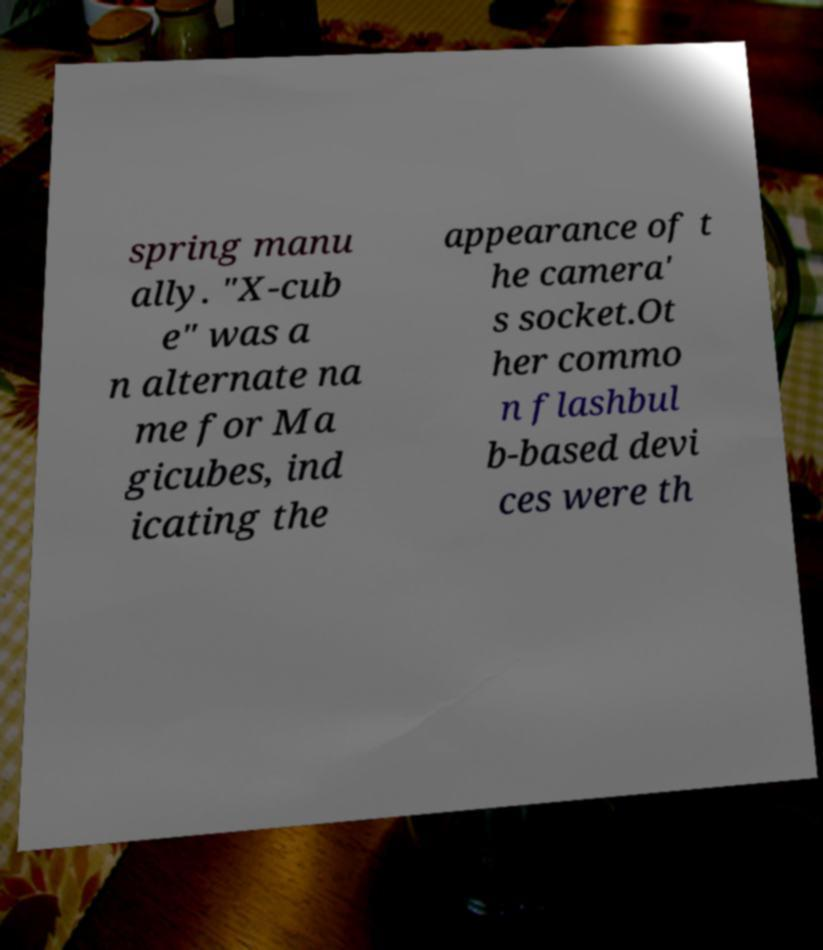Can you accurately transcribe the text from the provided image for me? spring manu ally. "X-cub e" was a n alternate na me for Ma gicubes, ind icating the appearance of t he camera' s socket.Ot her commo n flashbul b-based devi ces were th 